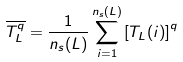<formula> <loc_0><loc_0><loc_500><loc_500>\overline { T _ { L } ^ { q } } = \frac { 1 } { n _ { s } ( L ) } \sum _ { i = 1 } ^ { n _ { s } ( L ) } \left [ T _ { L } ( i ) \right ] ^ { q }</formula> 